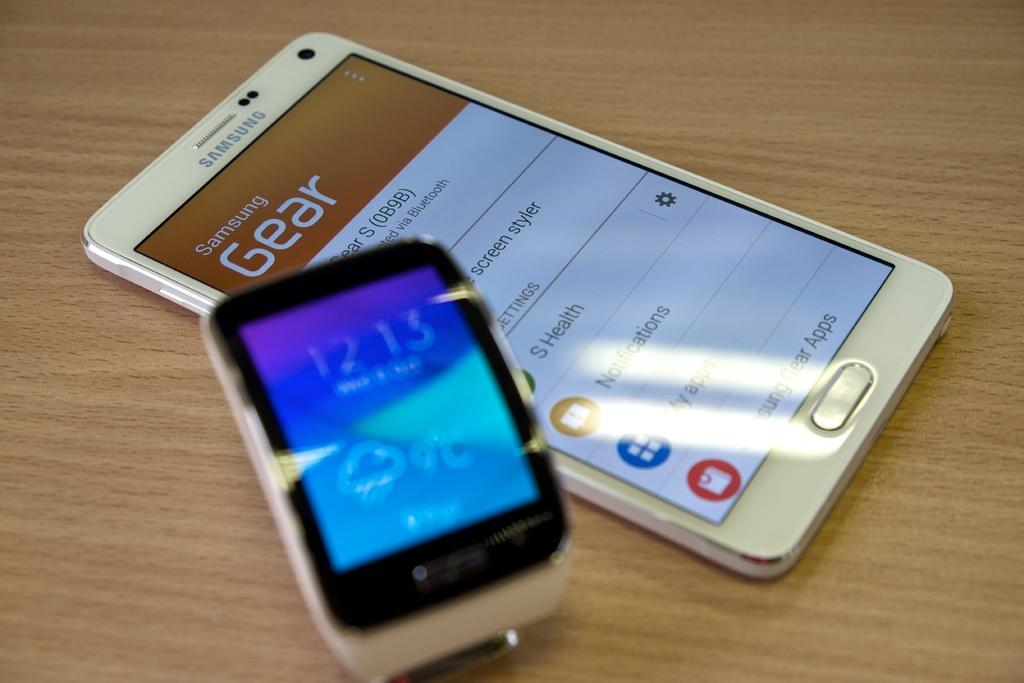<image>
Present a compact description of the photo's key features. A Samsung Gear cellphone laying on a table next to another electronic device showing the time. 